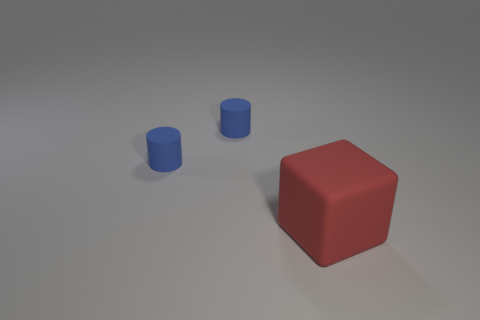What can you infer about the lighting in this scene? The lighting in the scene seems to be coming from above, as indicated by the soft shadows directly underneath the objects. The even and diffused lighting suggests an artificial light source, perhaps from a studio light, giving a calm and controlled impression to the scene. 